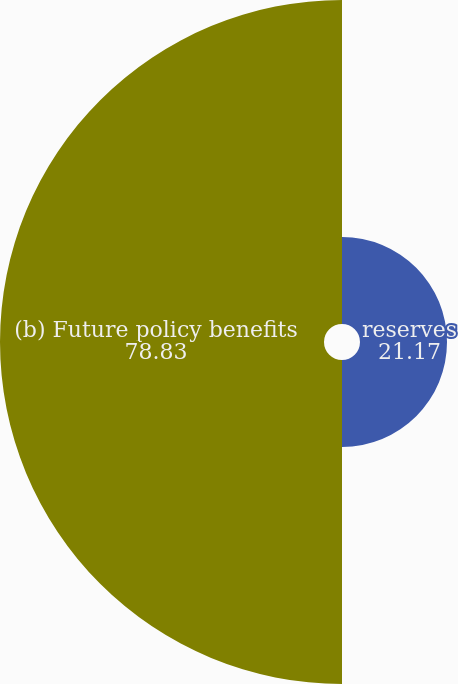Convert chart. <chart><loc_0><loc_0><loc_500><loc_500><pie_chart><fcel>reserves<fcel>(b) Future policy benefits<nl><fcel>21.17%<fcel>78.83%<nl></chart> 